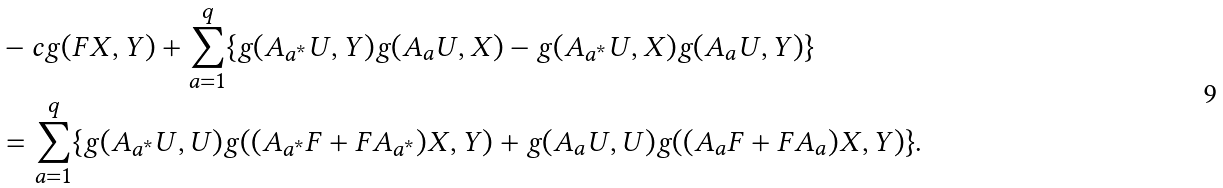<formula> <loc_0><loc_0><loc_500><loc_500>& - c g ( F X , Y ) + \sum _ { a = 1 } ^ { q } \{ g ( A _ { a ^ { * } } U , Y ) g ( A _ { a } U , X ) - g ( A _ { a ^ { * } } U , X ) g ( A _ { a } U , Y ) \} \\ & = \sum _ { a = 1 } ^ { q } \{ g ( A _ { a ^ { * } } U , U ) g ( ( A _ { a ^ { * } } F + F A _ { a ^ { * } } ) X , Y ) + g ( A _ { a } U , U ) g ( ( A _ { a } F + F A _ { a } ) X , Y ) \} .</formula> 